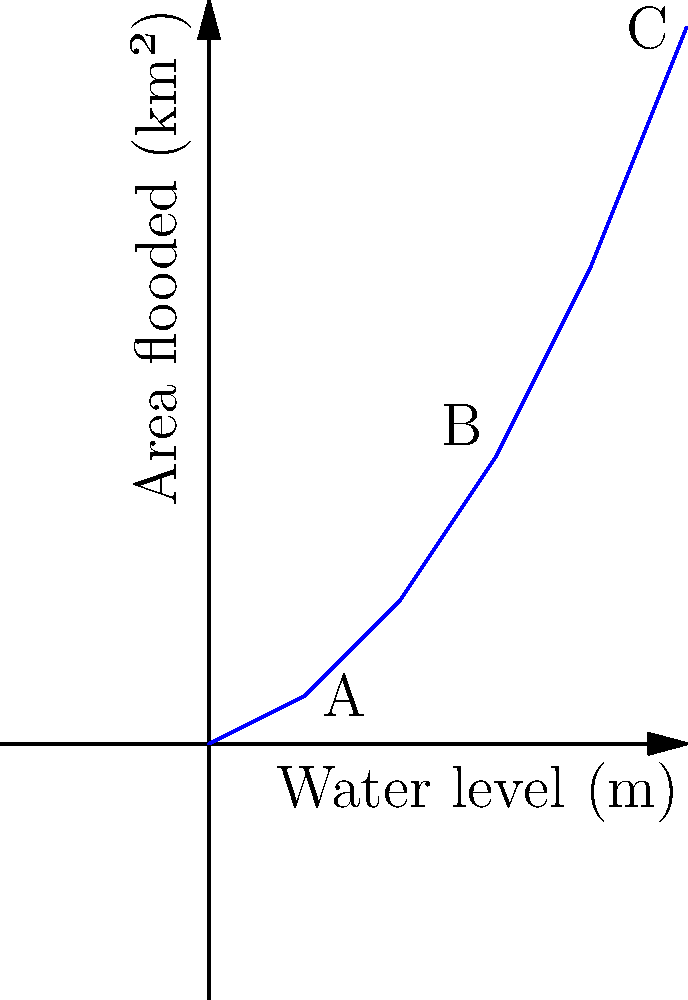Ein Staudammprojekt wird in einem Tal geplant. Die Grafik zeigt die Beziehung zwischen Wasserspiegel und überfluteter Fläche. Wenn der Wasserspiegel von Punkt A auf Punkt C ansteigt, um wie viel Prozent nimmt die überflutete Fläche zu? Um diese Frage zu beantworten, gehen wir schrittweise vor:

1. Identifizieren der relevanten Punkte:
   Punkt A: (10 m, 5 km²)
   Punkt C: (50 m, 75 km²)

2. Berechnen der Differenz der überfluteten Fläche:
   $\Delta \text{Fläche} = 75 \text{ km}² - 5 \text{ km}² = 70 \text{ km}²$

3. Berechnen der prozentualen Zunahme:
   $\text{Prozentuale Zunahme} = \frac{\Delta \text{Fläche}}{\text{Ursprungsfläche}} \times 100\%$
   $= \frac{70 \text{ km}²}{5 \text{ km}²} \times 100\% = 14 \times 100\% = 1400\%$

4. Überprüfen der Plausibilität:
   Die überflutete Fläche steigt von 5 km² auf 75 km², was einer Zunahme um das 15-fache entspricht. Dies stimmt mit unserer Berechnung von 1400% überein.
Answer: 1400% 